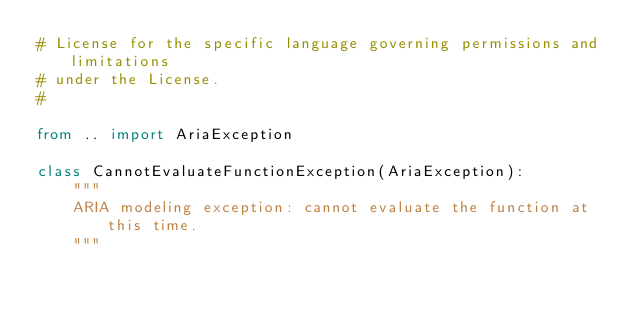<code> <loc_0><loc_0><loc_500><loc_500><_Python_># License for the specific language governing permissions and limitations
# under the License.
#

from .. import AriaException

class CannotEvaluateFunctionException(AriaException):
    """
    ARIA modeling exception: cannot evaluate the function at this time.
    """
</code> 